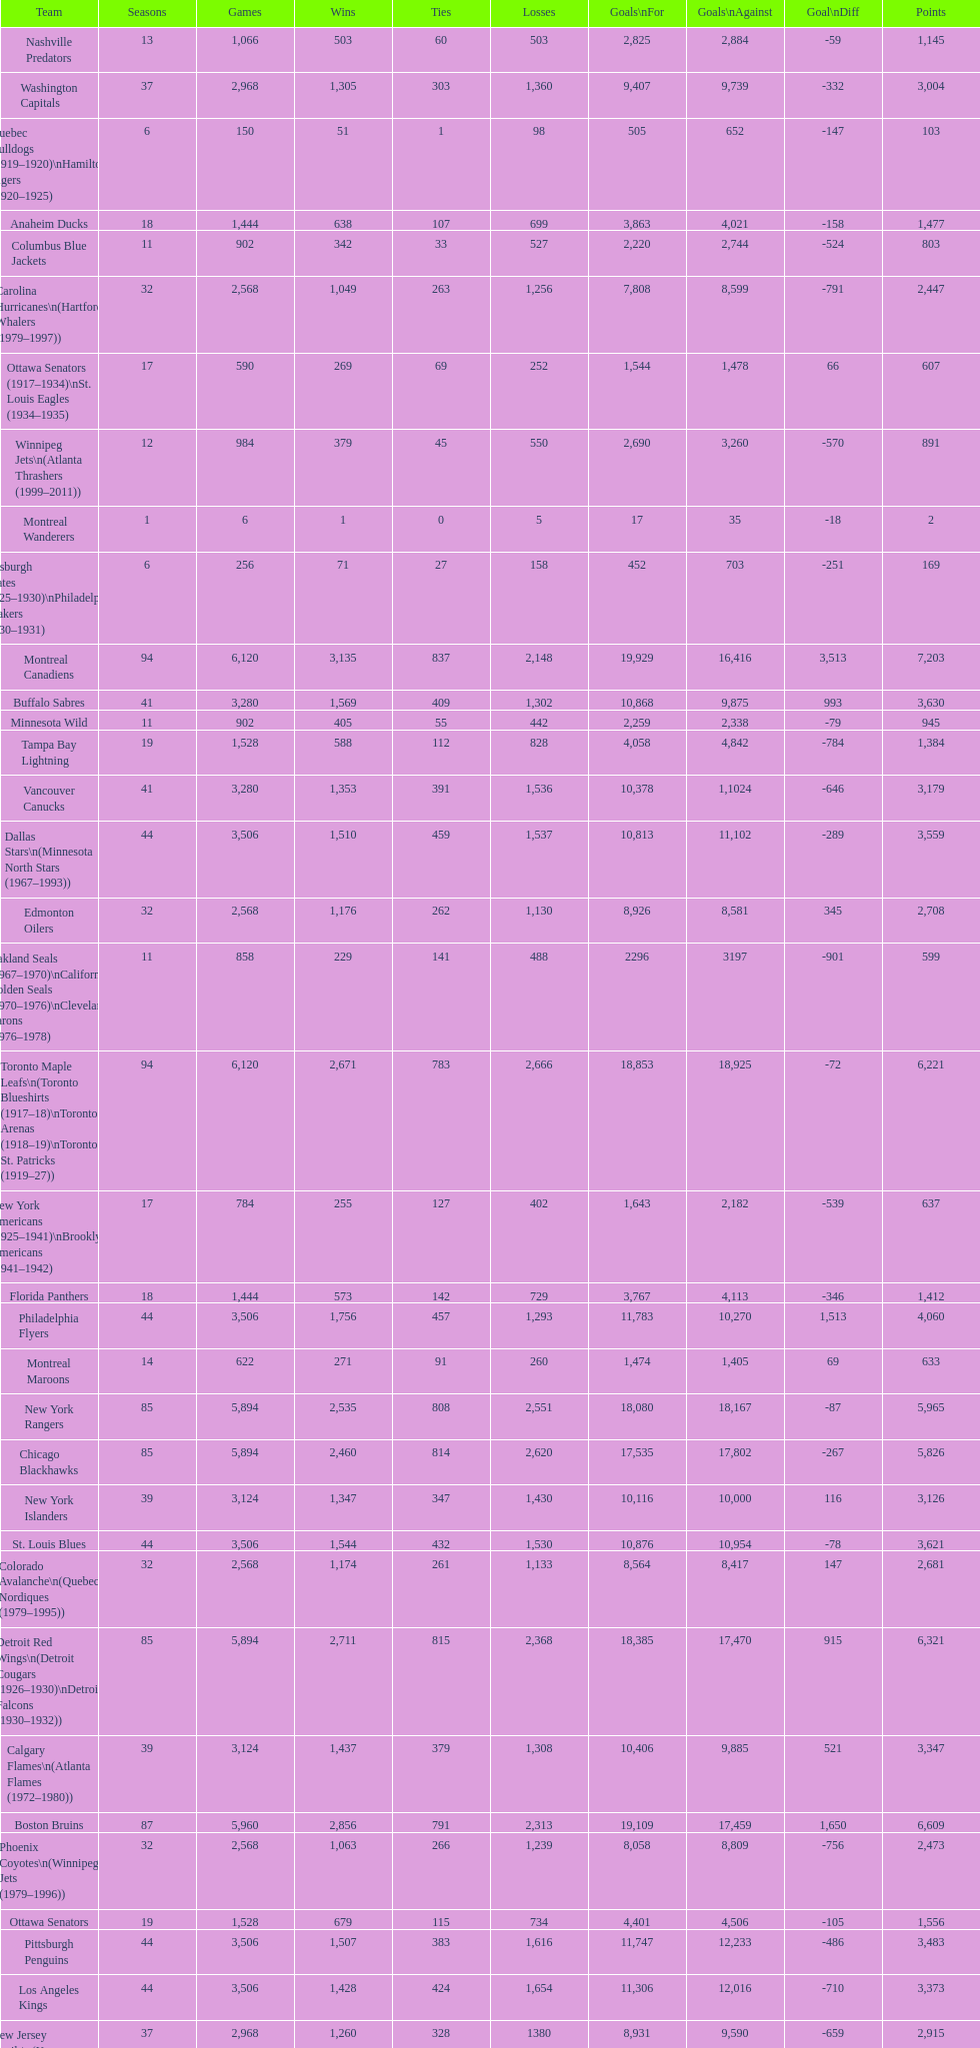Which team was last in terms of points up until this point? Montreal Wanderers. 